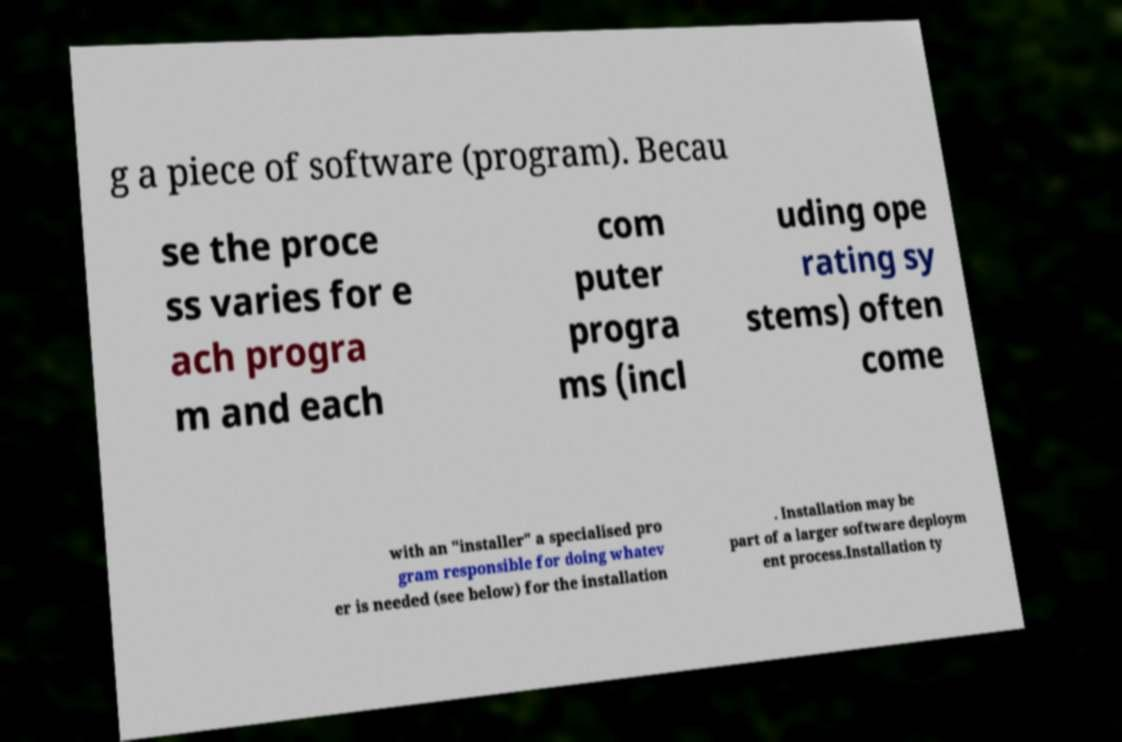For documentation purposes, I need the text within this image transcribed. Could you provide that? g a piece of software (program). Becau se the proce ss varies for e ach progra m and each com puter progra ms (incl uding ope rating sy stems) often come with an "installer" a specialised pro gram responsible for doing whatev er is needed (see below) for the installation . Installation may be part of a larger software deploym ent process.Installation ty 